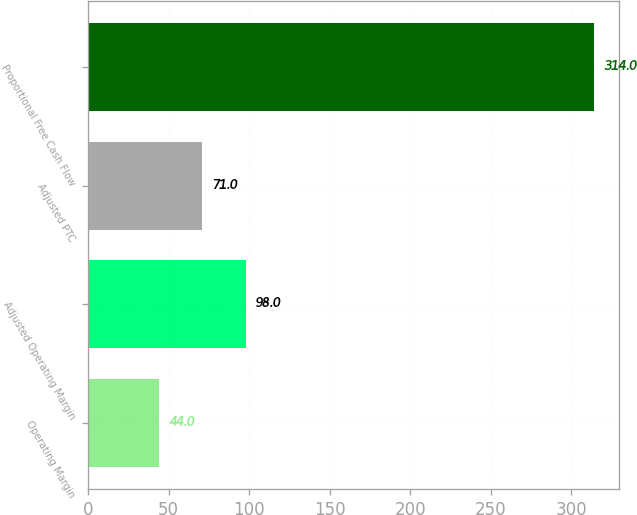<chart> <loc_0><loc_0><loc_500><loc_500><bar_chart><fcel>Operating Margin<fcel>Adjusted Operating Margin<fcel>Adjusted PTC<fcel>Proportional Free Cash Flow<nl><fcel>44<fcel>98<fcel>71<fcel>314<nl></chart> 